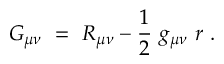Convert formula to latex. <formula><loc_0><loc_0><loc_500><loc_500>G _ { \mu \nu } \ = \ R _ { \mu \nu } - \frac { 1 } { 2 } \ g _ { \mu \nu } \ r \ .</formula> 